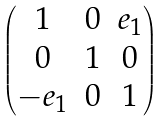<formula> <loc_0><loc_0><loc_500><loc_500>\begin{pmatrix} 1 & 0 & e _ { 1 } \\ 0 & 1 & 0 \\ - e _ { 1 } & 0 & 1 \end{pmatrix}</formula> 